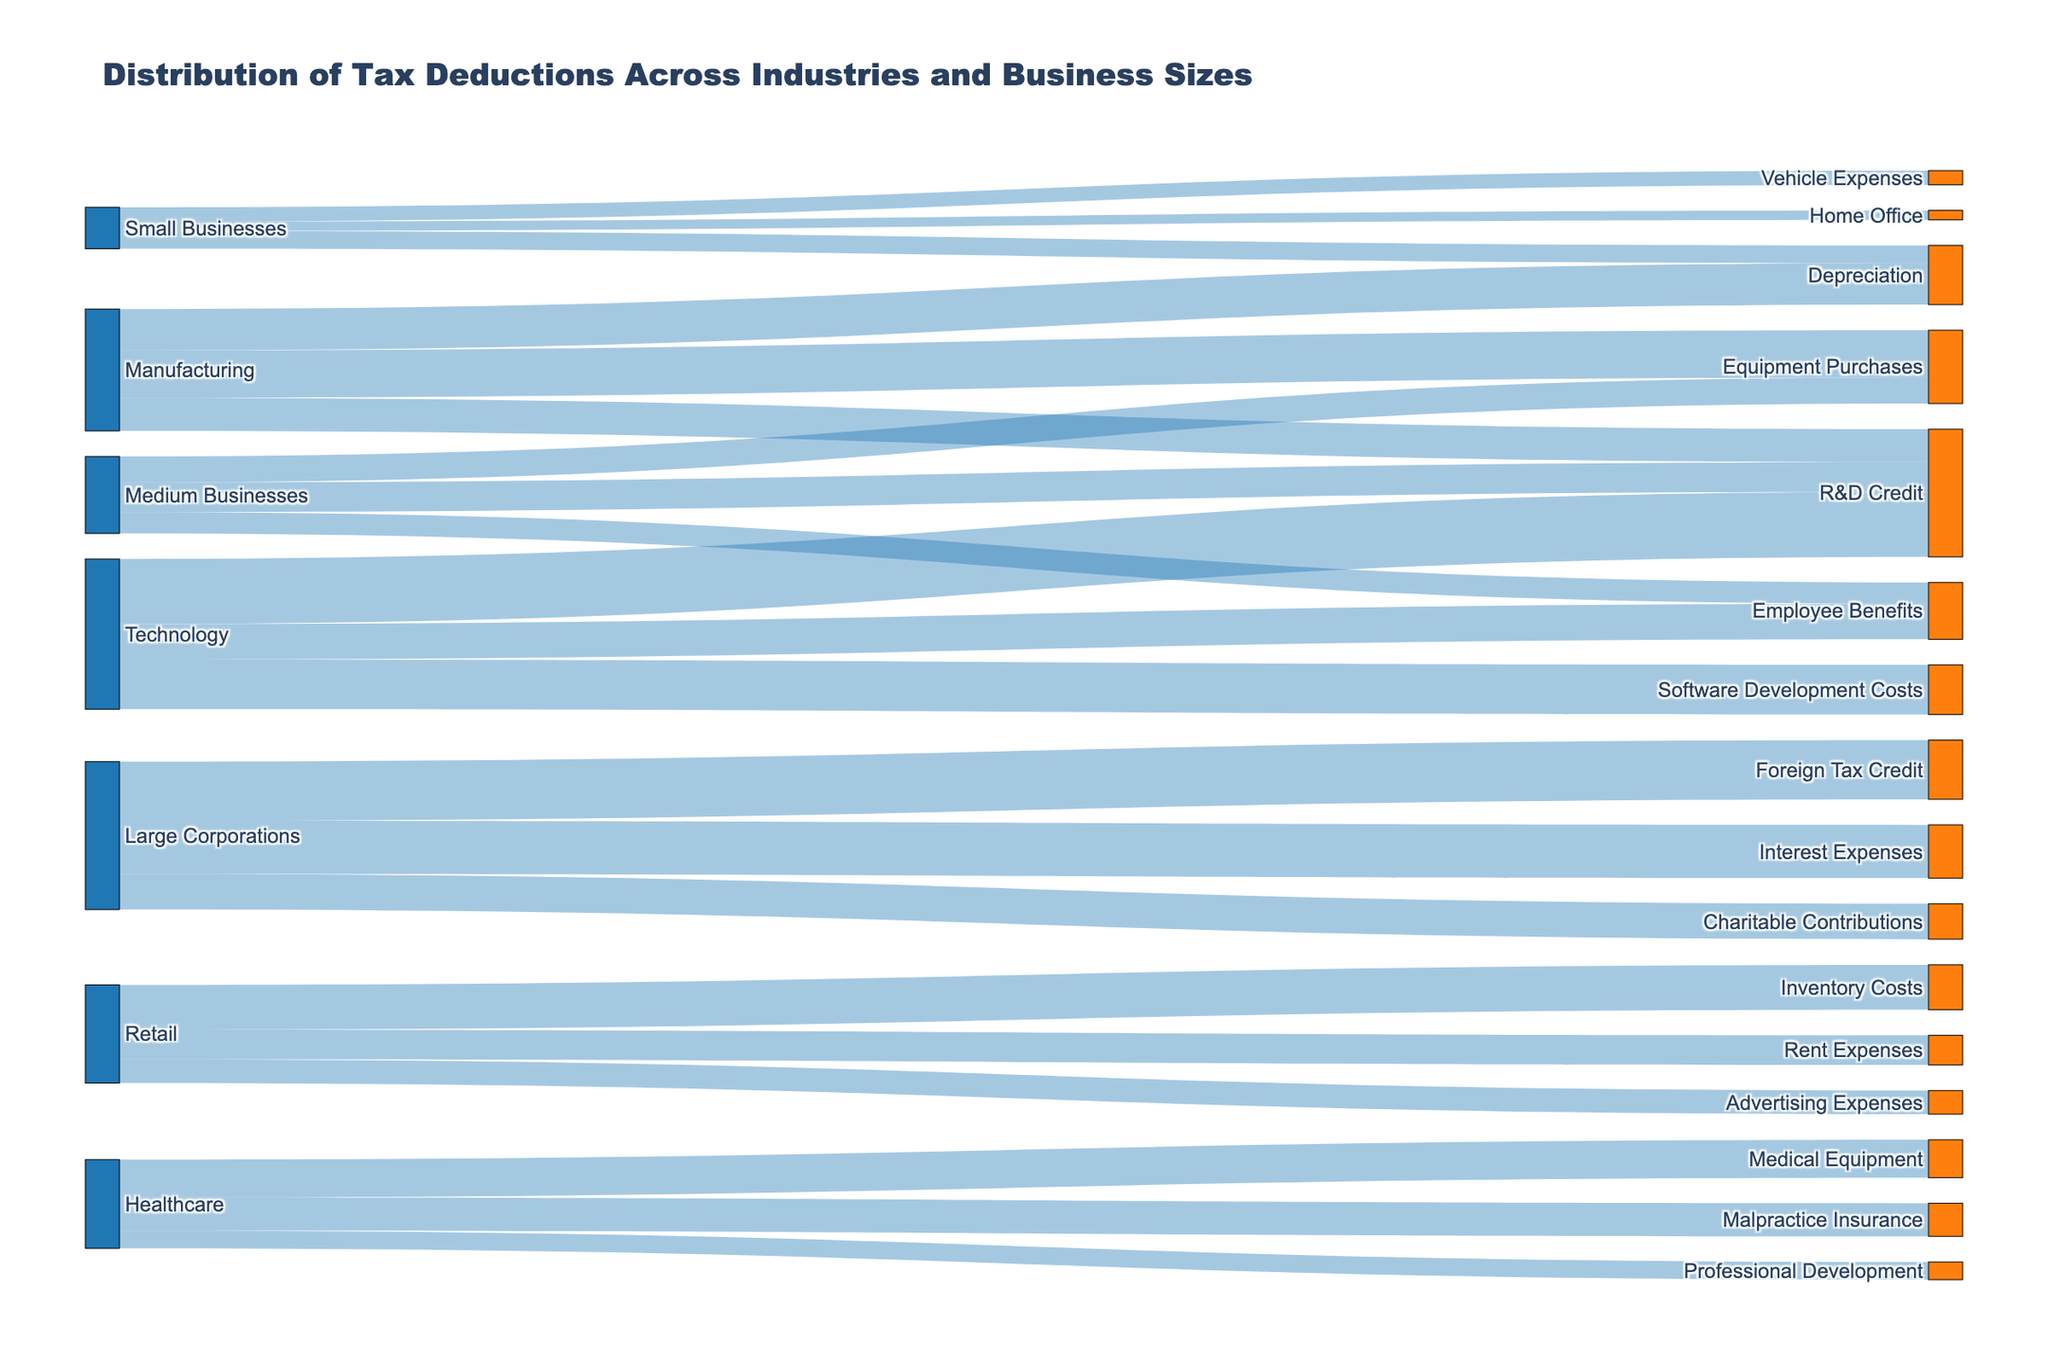What is the title of the Sankey diagram? The title of the Sankey diagram is displayed at the top of the figure. This text summarizes the main focus of the diagram.
Answer: Distribution of Tax Deductions Across Industries and Business Sizes How many types of tax deductions are shown in the diagram? By counting the unique labels in the target nodes (right-side nodes) of the diagram, you can determine the number of different tax deductions represented.
Answer: 15 Which category claims the highest value of tax deductions and what is this value? To find the category with the highest value of tax deductions, look for the target node with the largest value linked from the source. Check the value labels connected to 'Large Corporations' or 'Foreign Tax Credit' nodes.
Answer: Foreign Tax Credit, 50,000 Which businesses claim "R&D Credit" tax deductions, and what are the claimed amounts for each? Identify the source nodes that link to the "R&D Credit" target node and note the corresponding values. These represent the claims made by different businesses.
Answer: Medium Businesses: 25,000; Manufacturing: 28,000; Technology: 55,000 What is the total value of tax deductions claimed by Healthcare-related businesses? Sum up the values linked to the Healthcare source node: 32,000 (Medical Equipment) + 15,000 (Professional Development) + 28,000 (Malpractice Insurance).
Answer: 75,000 How do the total claims of Small Businesses compare to those of Medium Businesses? Calculate the total value of tax deductions for both Small Businesses and Medium Businesses by summing up their respective linked values. Compare the two sums.
Answer: Small Businesses: 35,000; Medium Businesses: 65,000 Which industry has the highest average value per tax deduction type? To find this, calculate the average value per tax deduction for each industry. Divide the sum of all values for each industry by the number of unique tax deduction types they claim.
Answer: Technology (average: 42,333) What is the most common type of tax deduction claimed across all businesses? Identify the tax deduction type (target node) that has the highest number of links (connections from source nodes). Count the number of links for each deduction type and find the maximum.
Answer: R&D Credit (claimed by 3 different business types) Which industry claims the most significant amount for Equipment Purchases, and what is the value? Look at the links connected to the Equipment Purchases target node and identify the source node with the highest linked value.
Answer: Manufacturing, 40,000 